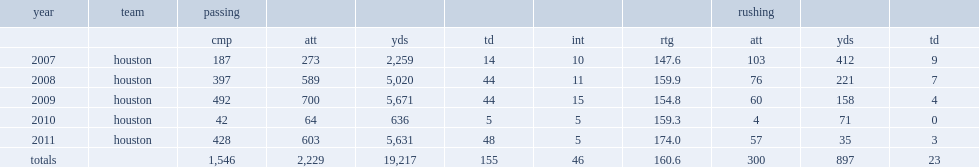How many passing yards did case keenum finish with in 2007? 2259.0. How many touchdowns did case keenum finish with in 2007? 14.0. How many interceptions did case keenum finish with in 2007? 10.0. 